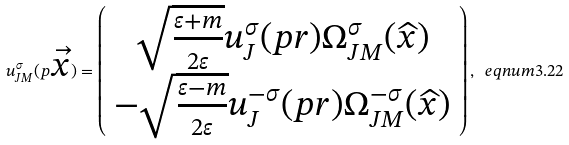<formula> <loc_0><loc_0><loc_500><loc_500>u _ { J M } ^ { \sigma } ( p \overrightarrow { x } ) = \left ( \begin{array} { c } \sqrt { \frac { \varepsilon + m } { 2 \varepsilon } } u _ { J } ^ { \sigma } ( p r ) \Omega _ { J M } ^ { \sigma } ( \widehat { x } ) \\ - \sqrt { \frac { \varepsilon - m } { 2 \varepsilon } } u _ { J } ^ { - \sigma } ( p r ) \Omega _ { J M } ^ { - \sigma } ( \widehat { x } ) \end{array} \right ) , \ e q n u m { 3 . 2 2 }</formula> 